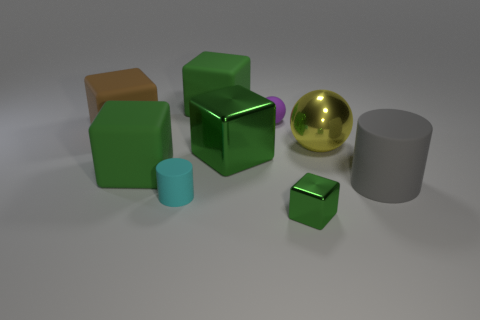Is the color of the big rubber block that is in front of the big yellow thing the same as the small metallic thing?
Provide a succinct answer. Yes. Are there more gray objects on the left side of the small ball than green cubes that are behind the yellow metallic object?
Provide a succinct answer. No. Is there anything else that has the same color as the tiny rubber cylinder?
Give a very brief answer. No. How many objects are either big green rubber spheres or metal cubes?
Ensure brevity in your answer.  2. Does the yellow thing that is right of the purple object have the same size as the large brown object?
Make the answer very short. Yes. What number of other things are the same size as the yellow metal sphere?
Offer a very short reply. 5. Are there any tiny green metallic spheres?
Your answer should be very brief. No. What size is the purple ball to the left of the large matte cylinder behind the small rubber cylinder?
Make the answer very short. Small. Is the color of the metallic thing that is left of the small shiny block the same as the tiny thing on the right side of the small sphere?
Keep it short and to the point. Yes. What is the color of the big rubber object that is on the left side of the tiny green metallic cube and right of the cyan cylinder?
Your response must be concise. Green. 